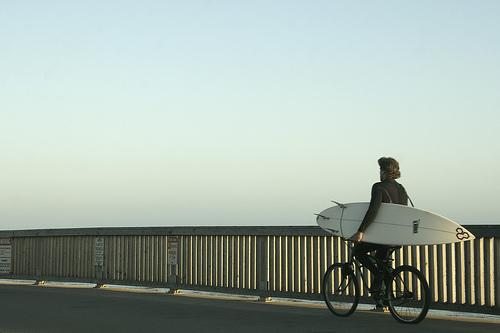What is the background of the image and how would you describe its color? The background of the image is blue and cloudless, showcasing a light blue sky. What is the color of the surfboard and how many fins does it have? The surfboard is white and has three fins in the tail. Explain what the man is doing with the surfboard and the bicycle. The man is riding a black bicycle while holding a white surfboard with his left hand under his arm. In a brief sentence, explain the man's appearance. The man has shaggy hair, wears a black wetsuit, and holds a white surfboard under his left arm while riding a bicycle. Describe how the man is holding the surfboard in relation to his body. The man is holding the surfboard under his left arm and against his side, parallel to his body. How many wheels are visible on the bicycle and what are their colors? There are two visible wheels on the black bicycle, a front wheel and a back wheel. Mention the two main actions the man is performing in the image. The man is riding a bicycle and carrying a surfboard under his left arm. List down the main objects and their properties identified in the image. Man with black wetsuit, white surfboard with three fins, black bicycle with two wheels, wooden fence, red and white sign on railing, blue cloudless sky. Describe the location and appearance of the sign in the image. The sign is red and white, and it is located on the slatted railing near the edge of the street. What kind of fence is in the image and what is it made of? There is a wooden slatted railing fence on the edge of the street. Identify the position of the surfboard in relation to the man. Under the left arm of the man What is happening around the man and surfboard? The man is on a bike, holding a surfboard, near to a wooden fence with a sign. What is the man doing with the surfboard? Holding the surfboard  Describe the bicycle's wheels. The front and back wheels of the bike are black. Describe the image in a 1970s surfer slang style. Righteous dude with shaggy hairdo, rockin' a black wetsuit, resting on a gnarly black bike, and holding a far out white surfboard, man! What type of suit is the man wearing? Black wet suit Create a scene of the beach featuring the man, the surfboard, and the bicycle. A beach scene with a man in a black wetsuit riding a black bike, carrying a white surfboard, with a blue sky and a wooden fence in the background. What color is the surfboard in the image?  White Imagine the scene taking place on a beach. The man in the black wetsuit carries the white surfboard while riding the black bicycle on a sandy beach with a clear blue sky and a wooden fence in the background. Explain the image in two sentences. A man in a black wetsuit is sitting on a black bicycle, holding a white surfboard under his left arm. A wooden fence with a warning sign is in the background. Is the man wearing a blue wet suit? The man is actually wearing a black wet suit, so this instruction is misleading. Which outdoor activity is the man in the image involved in? Riding a bike and carrying a surfboard Is the man carrying a surfboard or an umbrella? Carrying a surfboard Is the bike white in color? The bike is actually black, so this instruction is misleading. Is the surfboard under the man's right arm? The surfboard is actually under the man's left arm, so this instruction is misleading. What text can be found on the sign located on the fence? Warning sign Write a haiku about the scene. Man on trusty steed, Is the sky filled with clouds? The sky is actually cloudless and blue, so this instruction is misleading. How would you describe the surfboard's fins and nose? The surfboard has three fins in the tail and a pointy nose. Is there a green and yellow sign on the railing? The sign on the railing is red and white, so this instruction is misleading. Identify the number of wheels on the bike. Two wheels Is the man holding the surfboard with his right hand? The man is holding the surfboard with his left hand, so this instruction is misleading. 